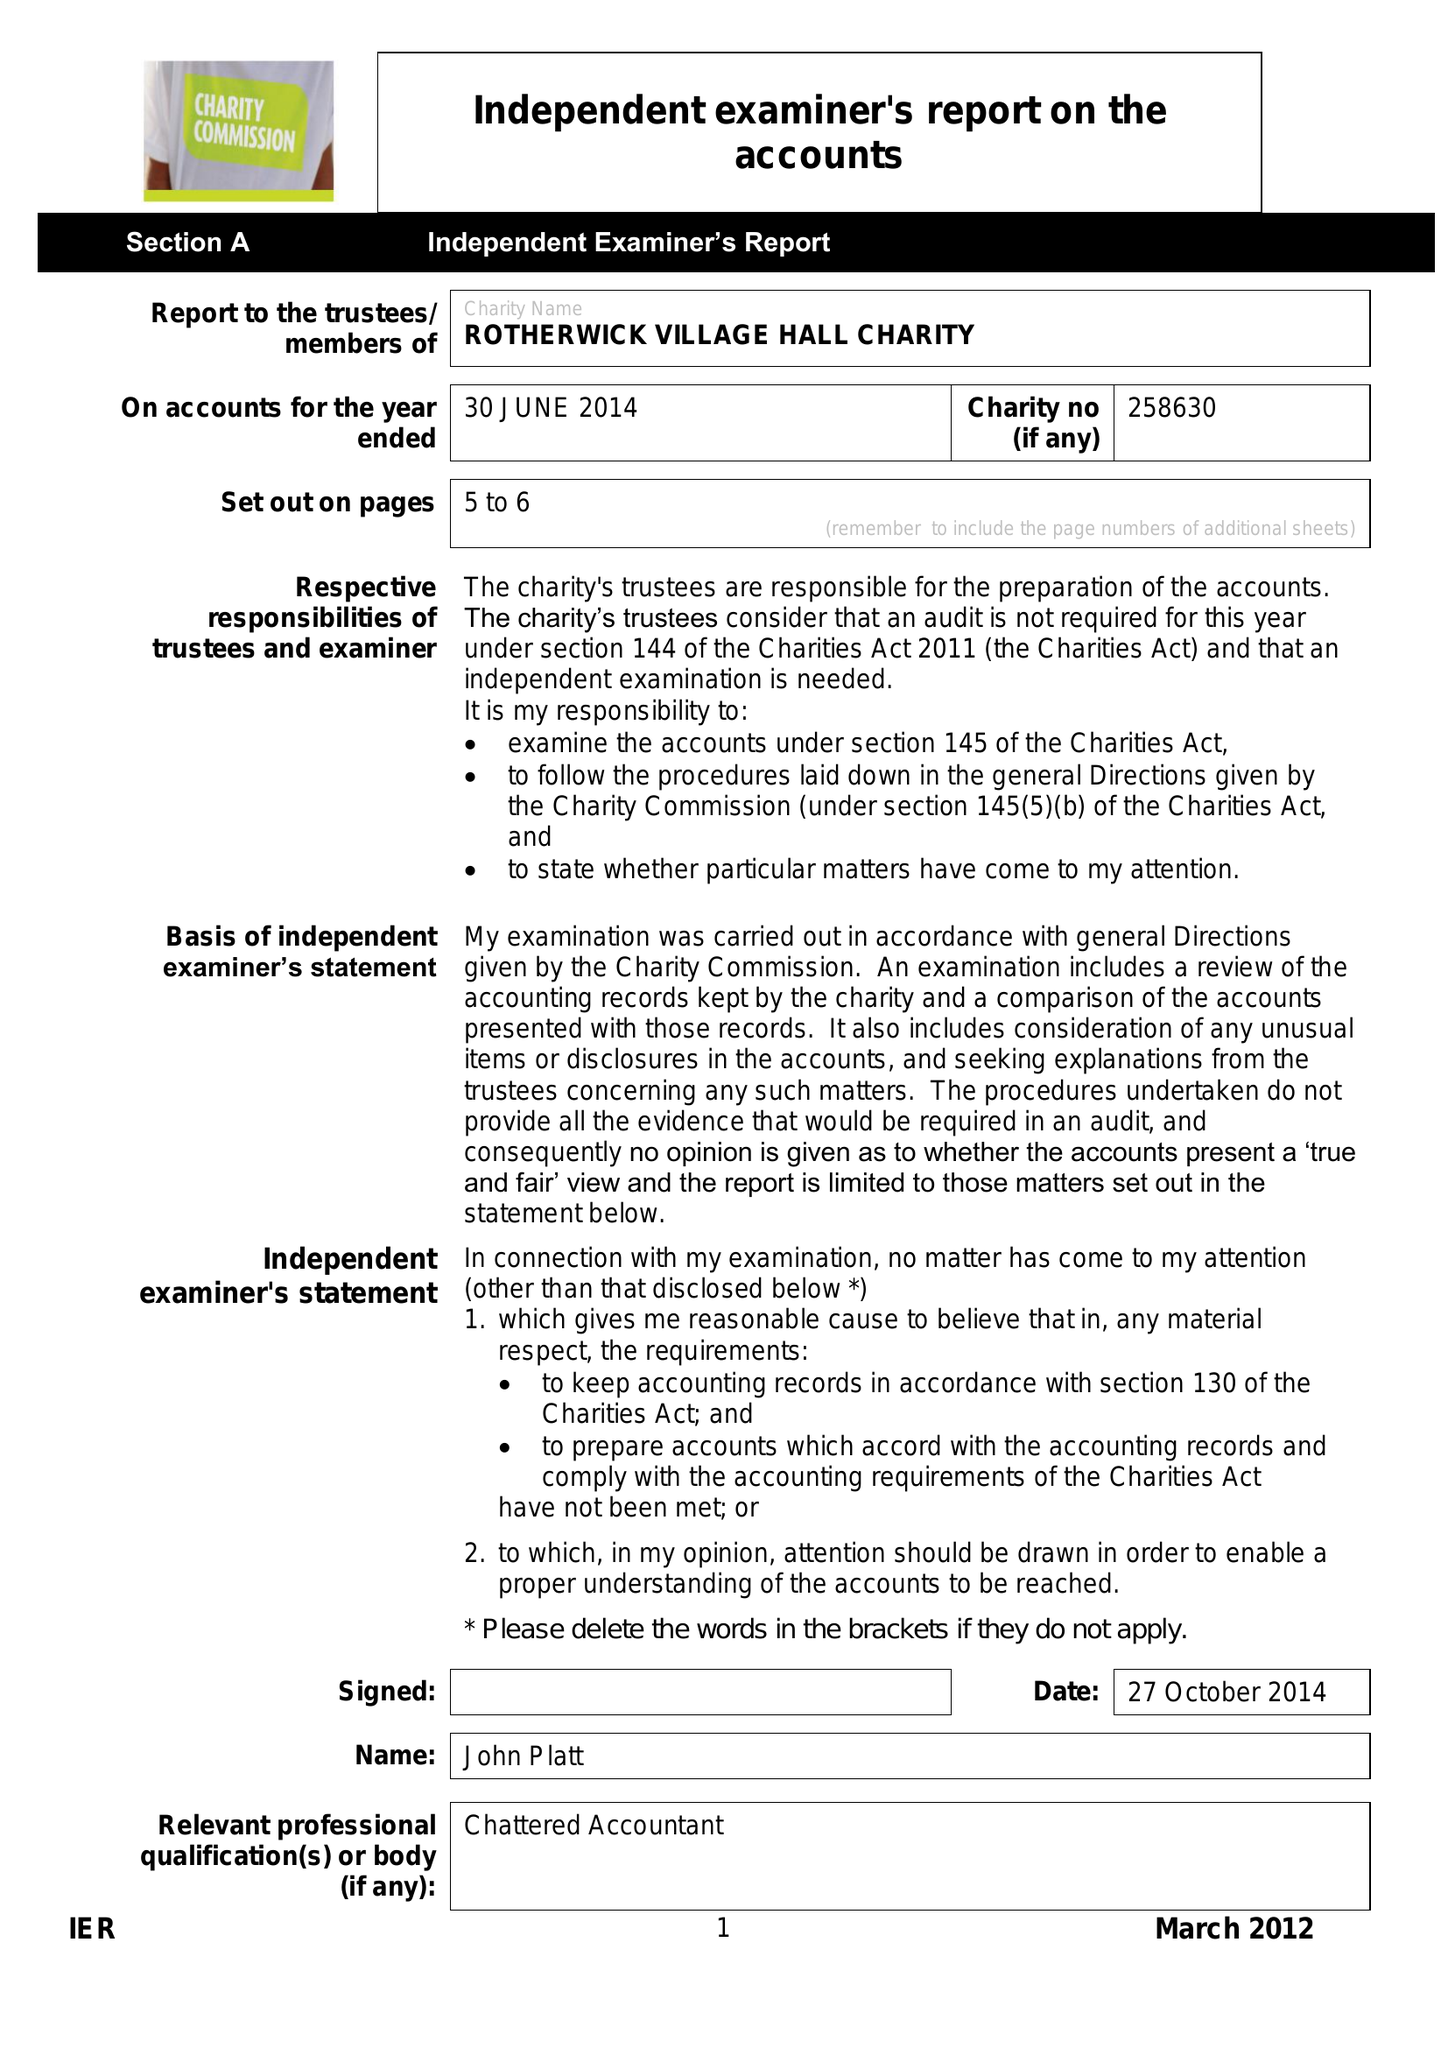What is the value for the address__postcode?
Answer the question using a single word or phrase. RG27 9BG 